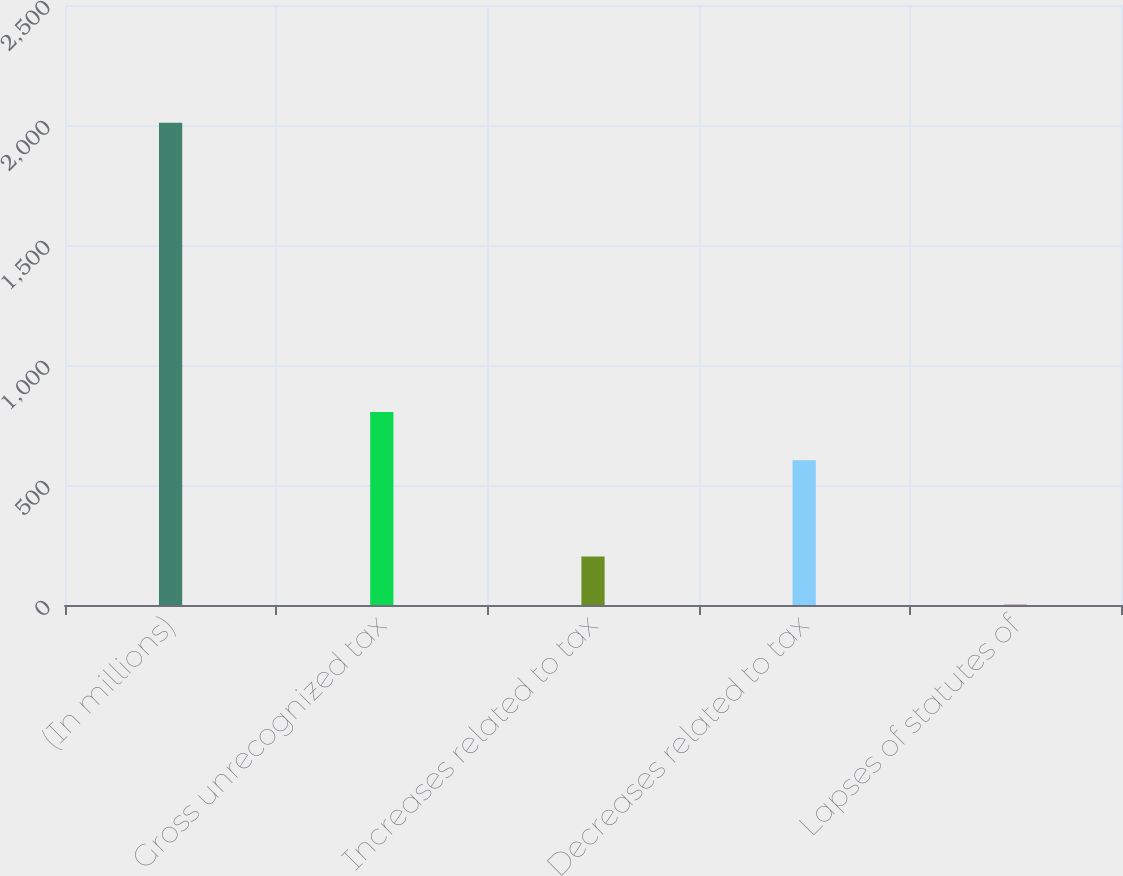<chart> <loc_0><loc_0><loc_500><loc_500><bar_chart><fcel>(In millions)<fcel>Gross unrecognized tax<fcel>Increases related to tax<fcel>Decreases related to tax<fcel>Lapses of statutes of<nl><fcel>2009<fcel>804.2<fcel>201.8<fcel>603.4<fcel>1<nl></chart> 